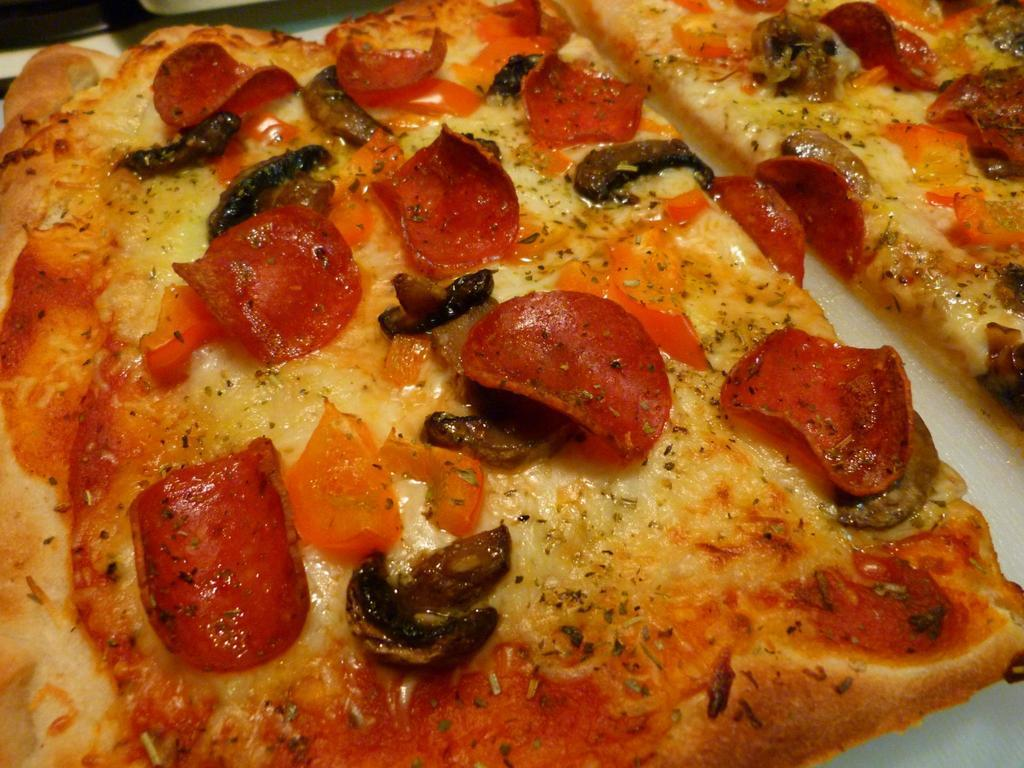What type of food is the main subject of the image? There is a pizza in the image. How is the pizza presented in the image? The pizza is on a plate. Can you see any fairies dancing around the pizza in the image? No, there are no fairies present in the image. What type of brick is used to make the pizza oven in the image? There is no pizza oven present in the image, so it is not possible to determine the type of brick used. 